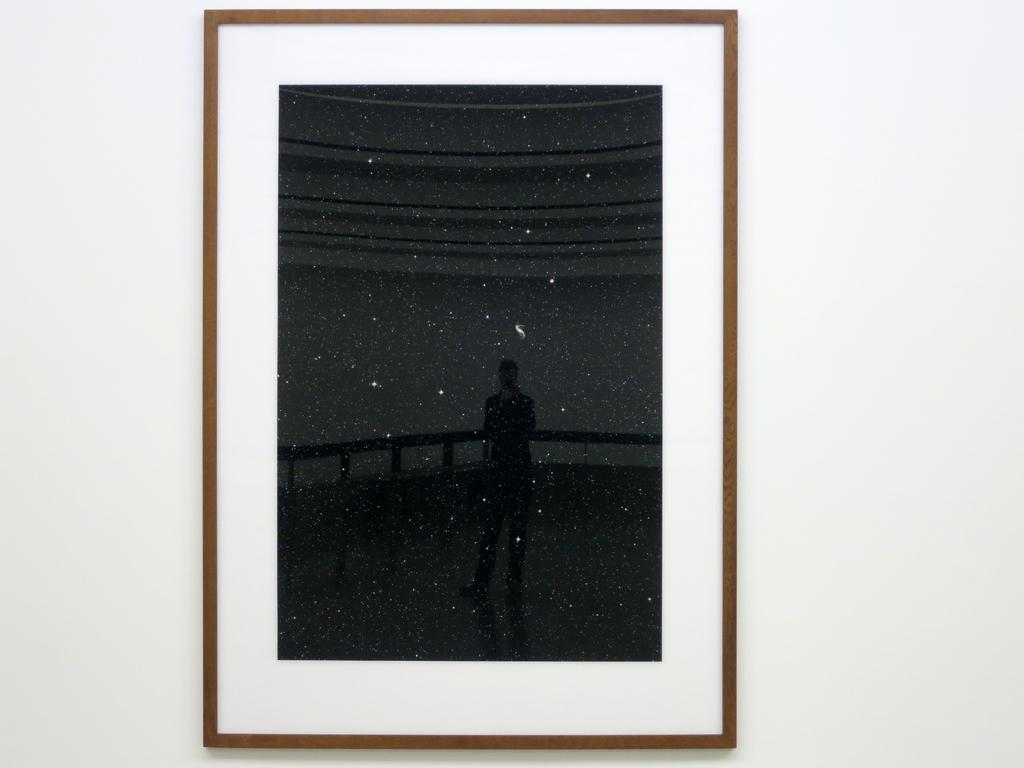What is the main subject in the center of the image? There is a wall in the center of the image. What is attached to the wall? There is a photo frame on the wall. What type of food is being prepared in the circle in the image? There is no circle or food preparation visible in the image; it only features a wall with a photo frame. 